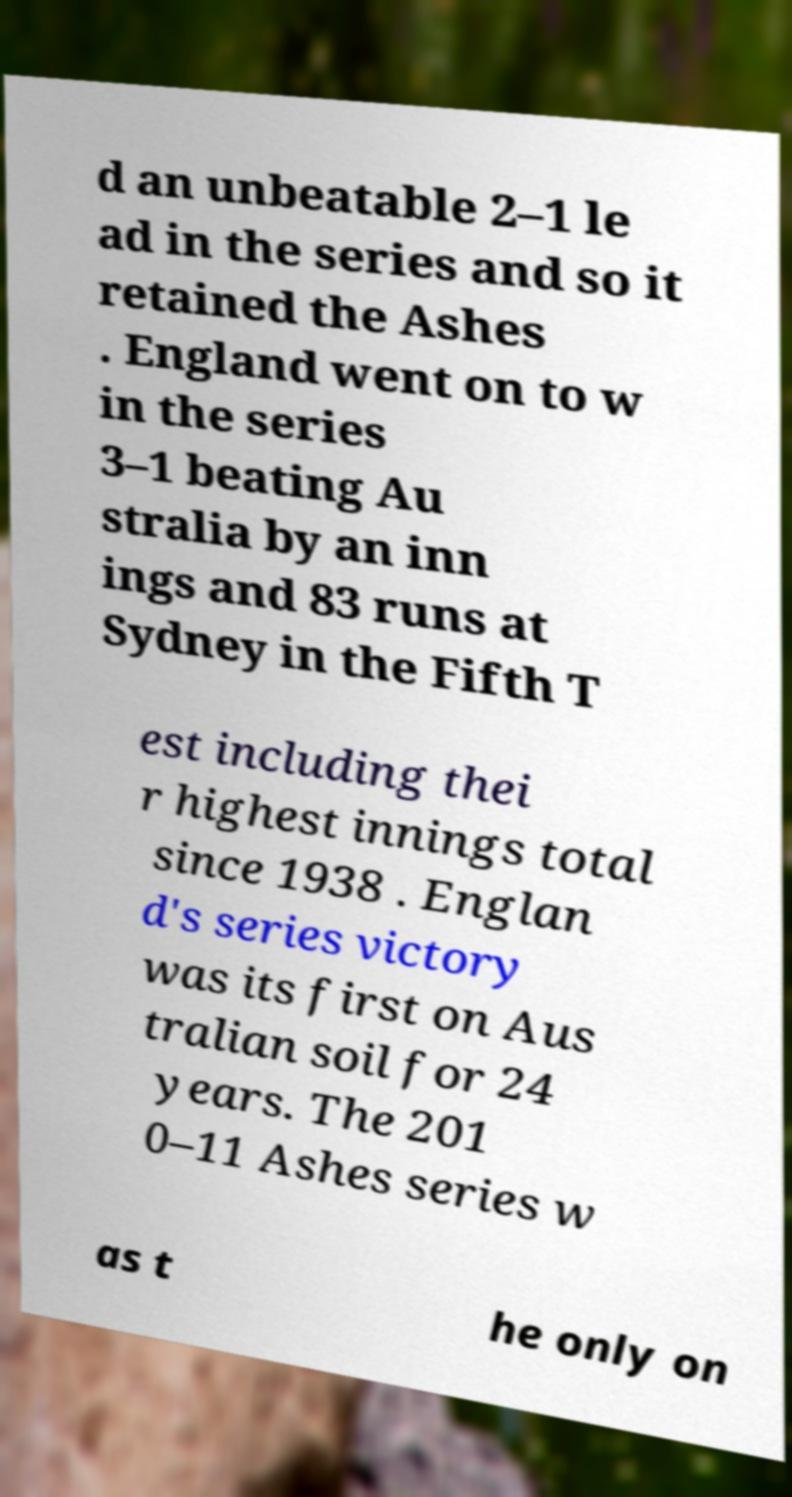Could you extract and type out the text from this image? d an unbeatable 2–1 le ad in the series and so it retained the Ashes . England went on to w in the series 3–1 beating Au stralia by an inn ings and 83 runs at Sydney in the Fifth T est including thei r highest innings total since 1938 . Englan d's series victory was its first on Aus tralian soil for 24 years. The 201 0–11 Ashes series w as t he only on 